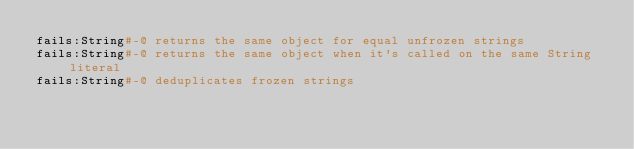Convert code to text. <code><loc_0><loc_0><loc_500><loc_500><_Ruby_>fails:String#-@ returns the same object for equal unfrozen strings
fails:String#-@ returns the same object when it's called on the same String literal
fails:String#-@ deduplicates frozen strings
</code> 